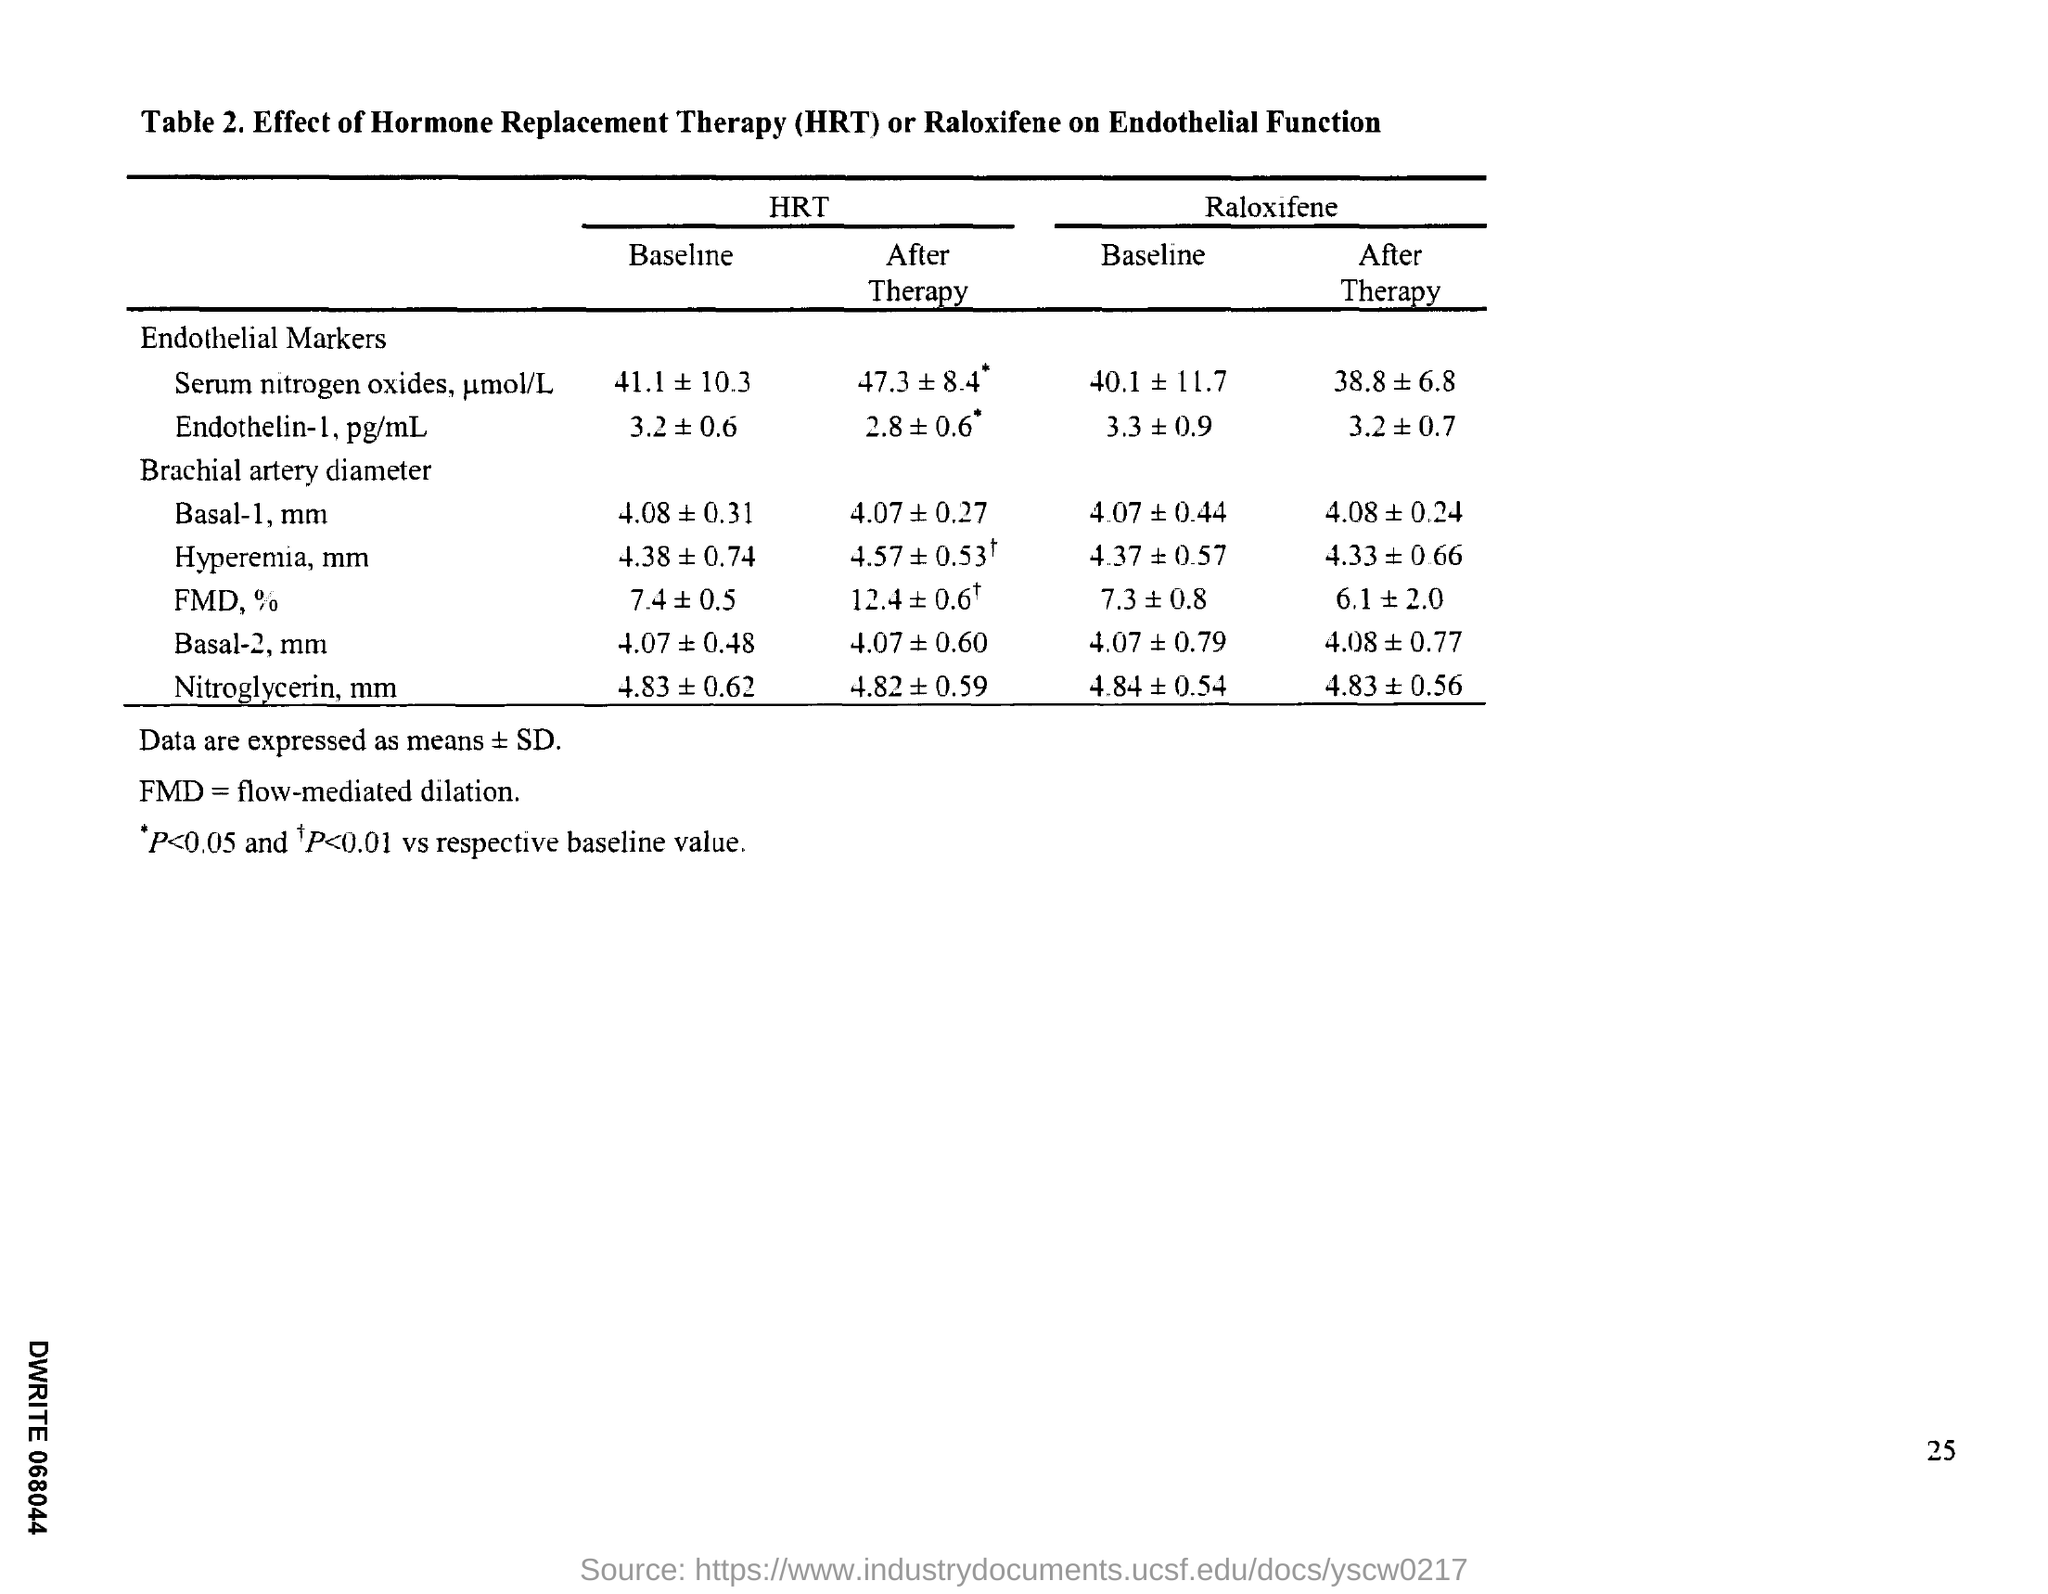Outline some significant characteristics in this image. The full form of FMD is Flow-Mediated Dilation. Hormone replacement therapy (HRT) is the administration of hormones to replace those that are deficient in the body. 